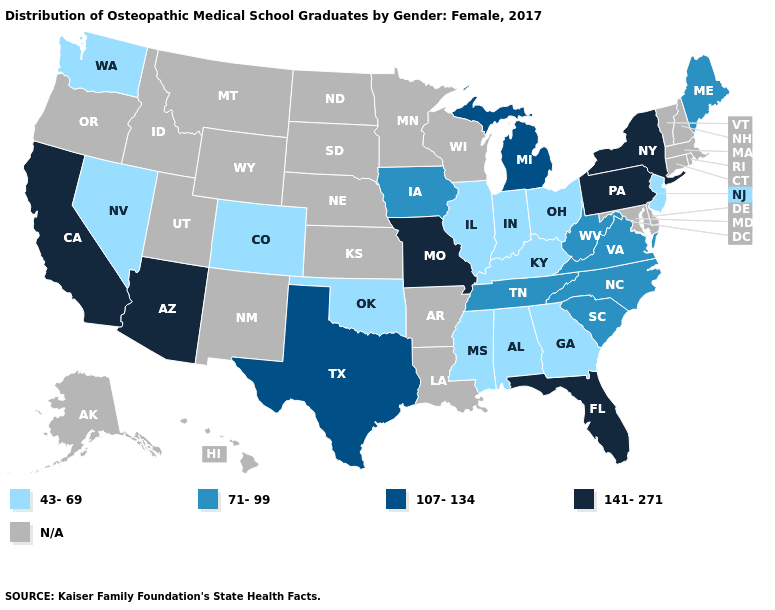Name the states that have a value in the range 141-271?
Quick response, please. Arizona, California, Florida, Missouri, New York, Pennsylvania. Among the states that border Oklahoma , does Colorado have the lowest value?
Be succinct. Yes. Does the first symbol in the legend represent the smallest category?
Keep it brief. Yes. Among the states that border Tennessee , does Alabama have the highest value?
Be succinct. No. Which states have the lowest value in the Northeast?
Concise answer only. New Jersey. What is the value of Ohio?
Concise answer only. 43-69. Which states hav the highest value in the Northeast?
Write a very short answer. New York, Pennsylvania. Among the states that border Missouri , which have the lowest value?
Quick response, please. Illinois, Kentucky, Oklahoma. What is the lowest value in the South?
Concise answer only. 43-69. Which states have the highest value in the USA?
Answer briefly. Arizona, California, Florida, Missouri, New York, Pennsylvania. Among the states that border Delaware , which have the highest value?
Give a very brief answer. Pennsylvania. Name the states that have a value in the range 107-134?
Answer briefly. Michigan, Texas. Name the states that have a value in the range 43-69?
Write a very short answer. Alabama, Colorado, Georgia, Illinois, Indiana, Kentucky, Mississippi, Nevada, New Jersey, Ohio, Oklahoma, Washington. Name the states that have a value in the range 43-69?
Write a very short answer. Alabama, Colorado, Georgia, Illinois, Indiana, Kentucky, Mississippi, Nevada, New Jersey, Ohio, Oklahoma, Washington. 